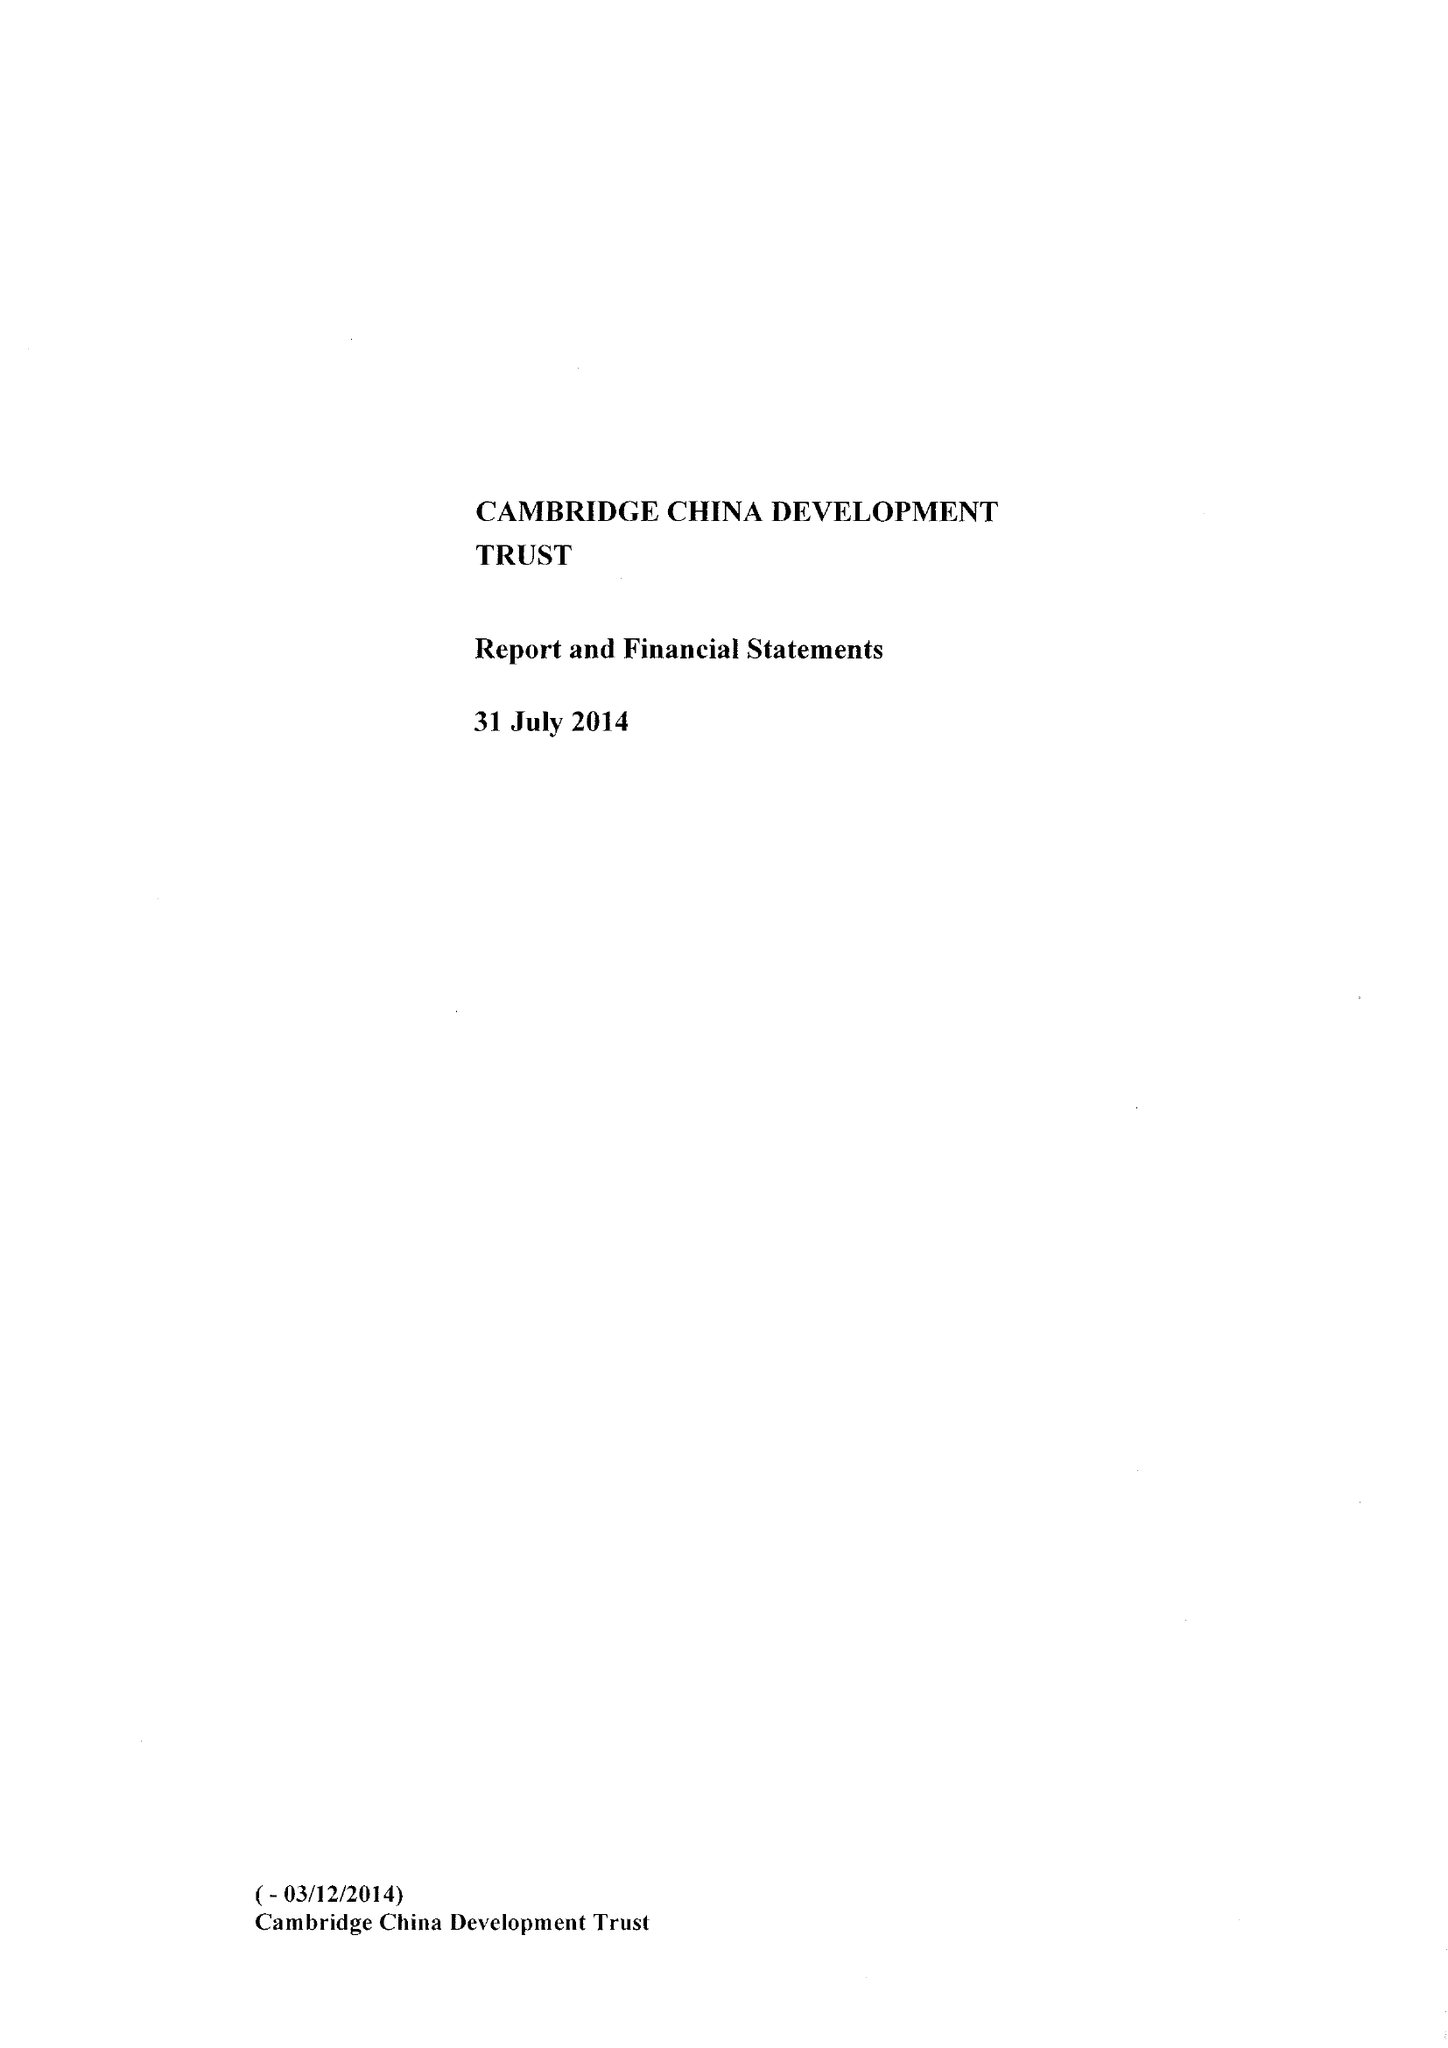What is the value for the charity_number?
Answer the question using a single word or phrase. 1111605 